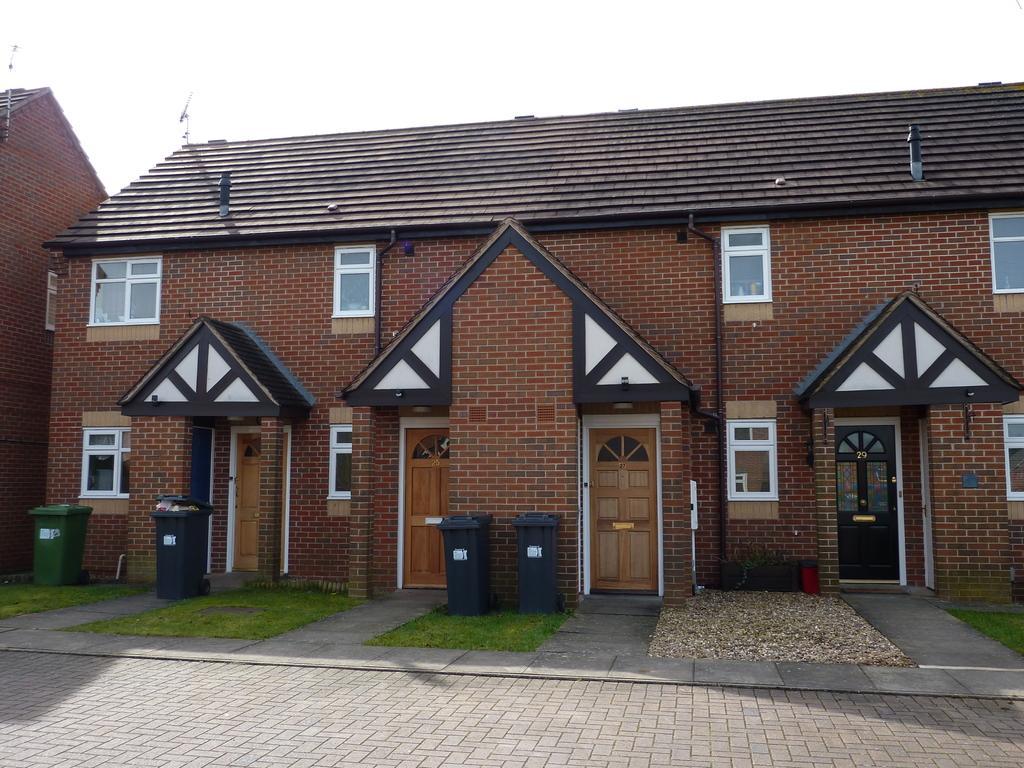In one or two sentences, can you explain what this image depicts? In this picture there are buildings. In the foreground there are dustbins and there is a plant. On the top of the building there are roof tiles and there are pipes on the wall. At the top there is sky. At the bottom there is grass and there is a road. 